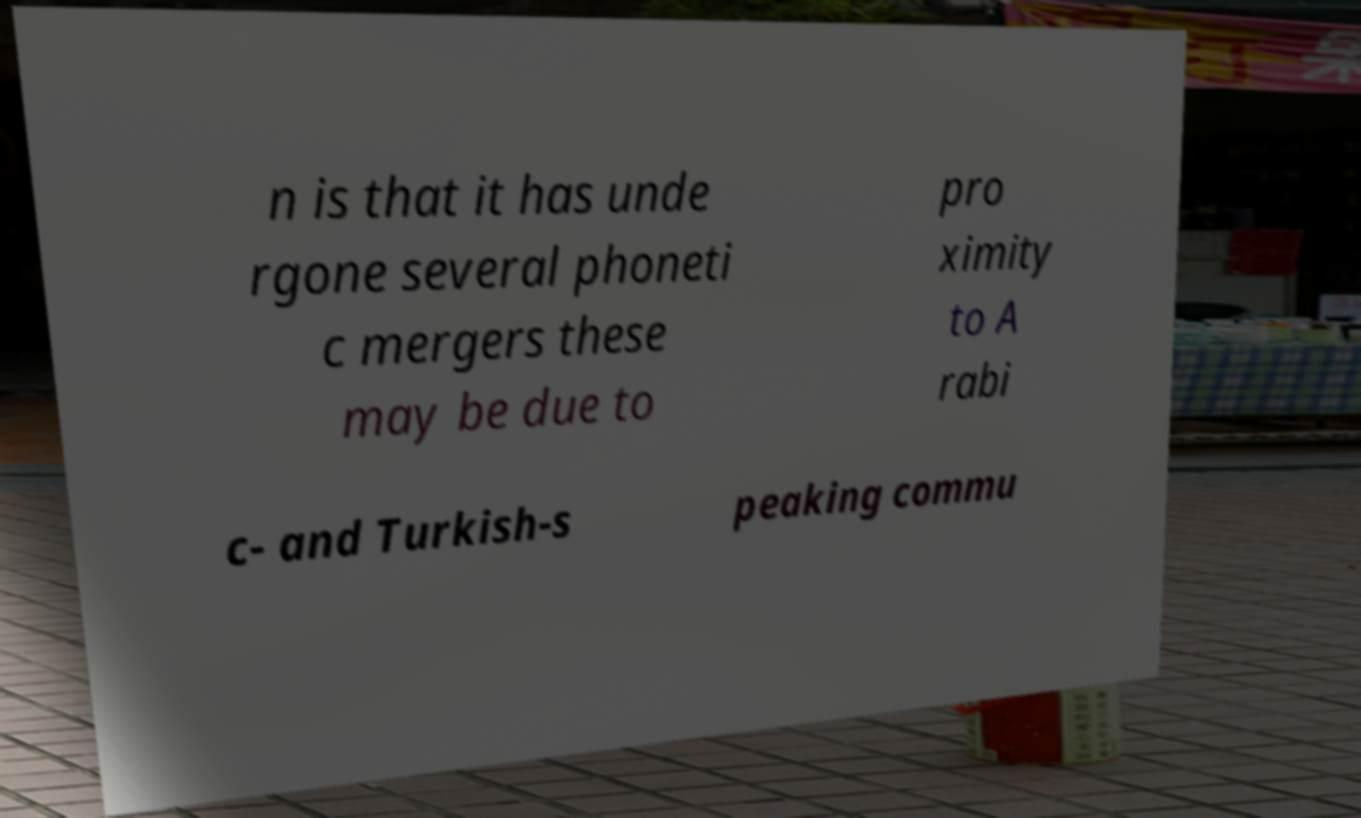Can you accurately transcribe the text from the provided image for me? n is that it has unde rgone several phoneti c mergers these may be due to pro ximity to A rabi c- and Turkish-s peaking commu 